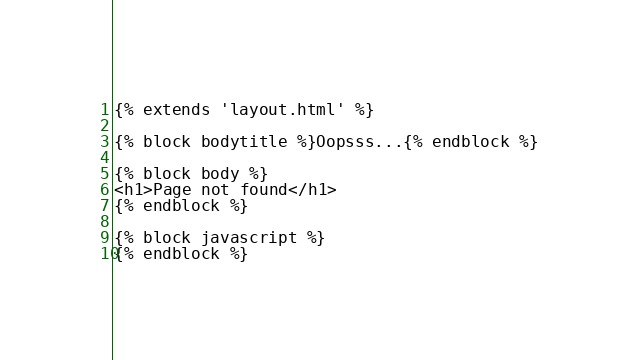Convert code to text. <code><loc_0><loc_0><loc_500><loc_500><_HTML_>{% extends 'layout.html' %}

{% block bodytitle %}Oopsss...{% endblock %}

{% block body %}
<h1>Page not found</h1>
{% endblock %}

{% block javascript %}
{% endblock %}
</code> 